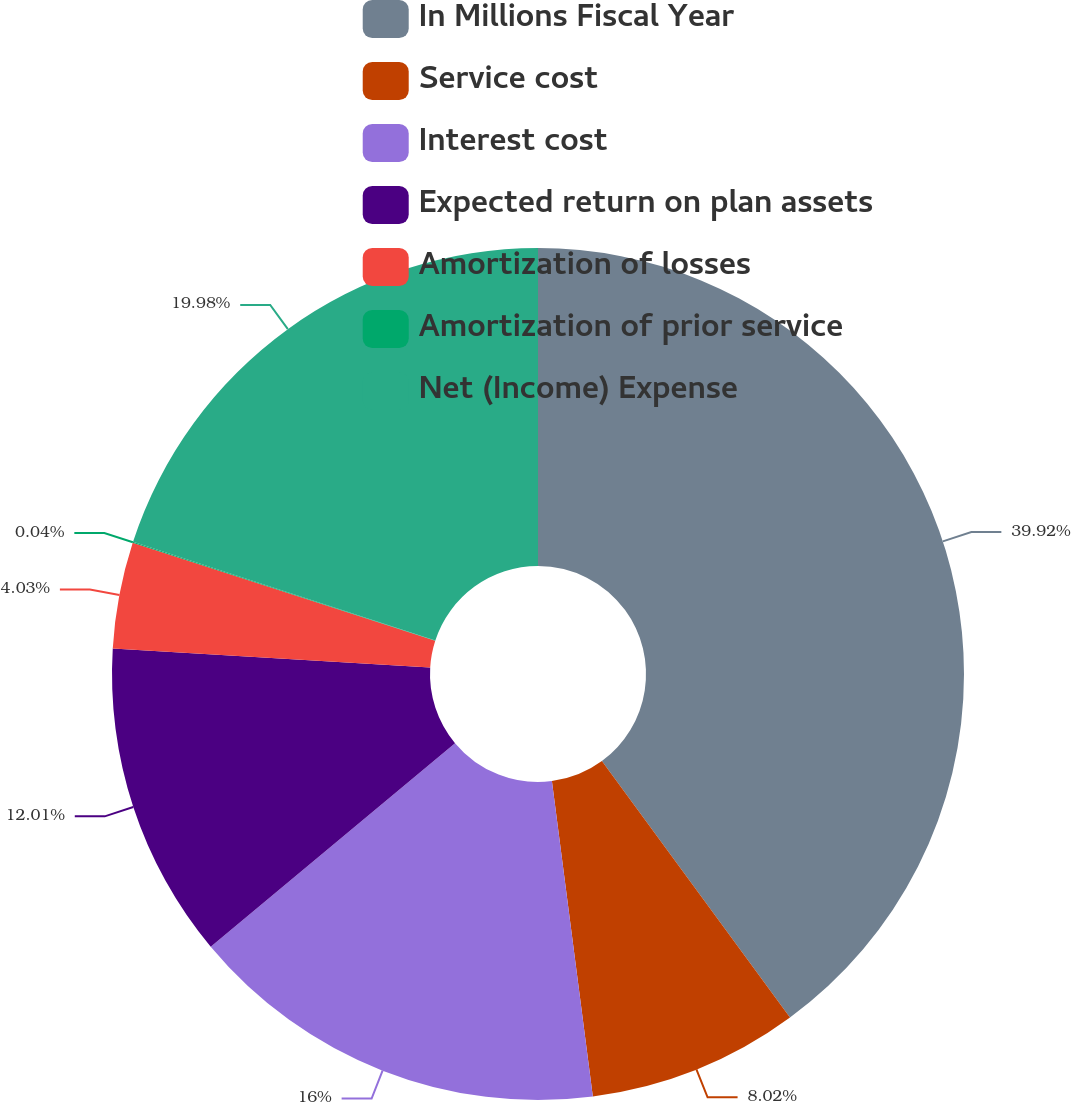Convert chart to OTSL. <chart><loc_0><loc_0><loc_500><loc_500><pie_chart><fcel>In Millions Fiscal Year<fcel>Service cost<fcel>Interest cost<fcel>Expected return on plan assets<fcel>Amortization of losses<fcel>Amortization of prior service<fcel>Net (Income) Expense<nl><fcel>39.93%<fcel>8.02%<fcel>16.0%<fcel>12.01%<fcel>4.03%<fcel>0.04%<fcel>19.98%<nl></chart> 